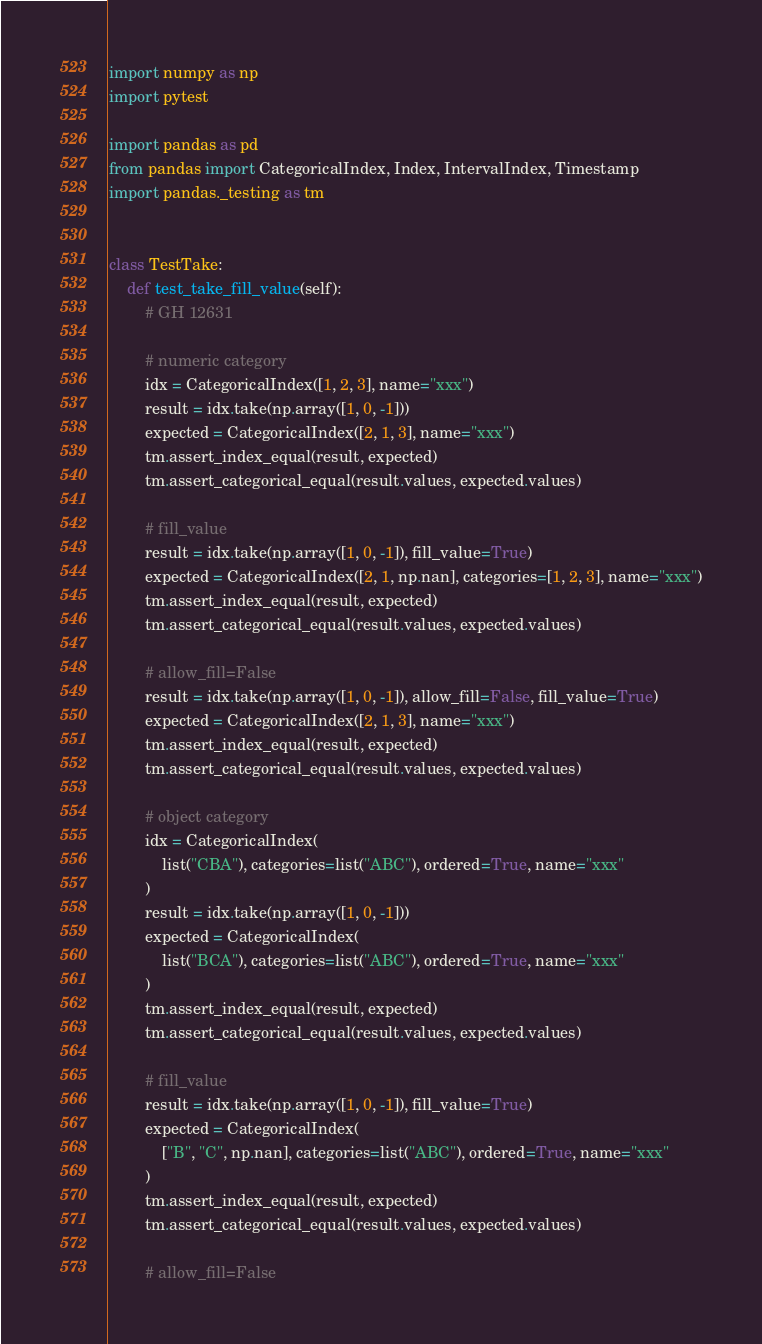<code> <loc_0><loc_0><loc_500><loc_500><_Python_>import numpy as np
import pytest

import pandas as pd
from pandas import CategoricalIndex, Index, IntervalIndex, Timestamp
import pandas._testing as tm


class TestTake:
    def test_take_fill_value(self):
        # GH 12631

        # numeric category
        idx = CategoricalIndex([1, 2, 3], name="xxx")
        result = idx.take(np.array([1, 0, -1]))
        expected = CategoricalIndex([2, 1, 3], name="xxx")
        tm.assert_index_equal(result, expected)
        tm.assert_categorical_equal(result.values, expected.values)

        # fill_value
        result = idx.take(np.array([1, 0, -1]), fill_value=True)
        expected = CategoricalIndex([2, 1, np.nan], categories=[1, 2, 3], name="xxx")
        tm.assert_index_equal(result, expected)
        tm.assert_categorical_equal(result.values, expected.values)

        # allow_fill=False
        result = idx.take(np.array([1, 0, -1]), allow_fill=False, fill_value=True)
        expected = CategoricalIndex([2, 1, 3], name="xxx")
        tm.assert_index_equal(result, expected)
        tm.assert_categorical_equal(result.values, expected.values)

        # object category
        idx = CategoricalIndex(
            list("CBA"), categories=list("ABC"), ordered=True, name="xxx"
        )
        result = idx.take(np.array([1, 0, -1]))
        expected = CategoricalIndex(
            list("BCA"), categories=list("ABC"), ordered=True, name="xxx"
        )
        tm.assert_index_equal(result, expected)
        tm.assert_categorical_equal(result.values, expected.values)

        # fill_value
        result = idx.take(np.array([1, 0, -1]), fill_value=True)
        expected = CategoricalIndex(
            ["B", "C", np.nan], categories=list("ABC"), ordered=True, name="xxx"
        )
        tm.assert_index_equal(result, expected)
        tm.assert_categorical_equal(result.values, expected.values)

        # allow_fill=False</code> 